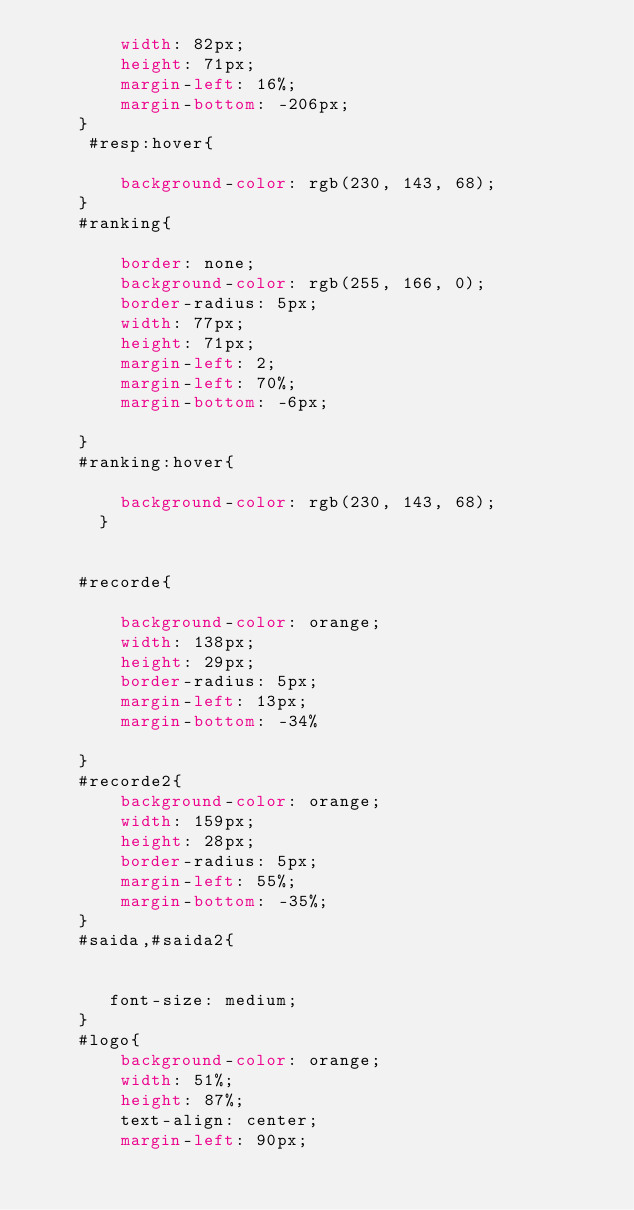<code> <loc_0><loc_0><loc_500><loc_500><_CSS_>        width: 82px;
        height: 71px;
        margin-left: 16%;
        margin-bottom: -206px;
    }
     #resp:hover{
    
        background-color: rgb(230, 143, 68);
    }
    #ranking{
    
        border: none;
        background-color: rgb(255, 166, 0);
        border-radius: 5px;
        width: 77px;
        height: 71px;
        margin-left: 2;
        margin-left: 70%;
        margin-bottom: -6px;
    
    }
    #ranking:hover{

        background-color: rgb(230, 143, 68);
      }
      
    
    #recorde{
    
        background-color: orange;
        width: 138px;
        height: 29px;
        border-radius: 5px;
        margin-left: 13px;
        margin-bottom: -34%
    
    }
    #recorde2{
        background-color: orange;
        width: 159px;
        height: 28px;
        border-radius: 5px;
        margin-left: 55%;
        margin-bottom: -35%;
    }
    #saida,#saida2{
    
    
       font-size: medium;
    }
    #logo{
        background-color: orange;
        width: 51%;
        height: 87%;
        text-align: center;
        margin-left: 90px;</code> 